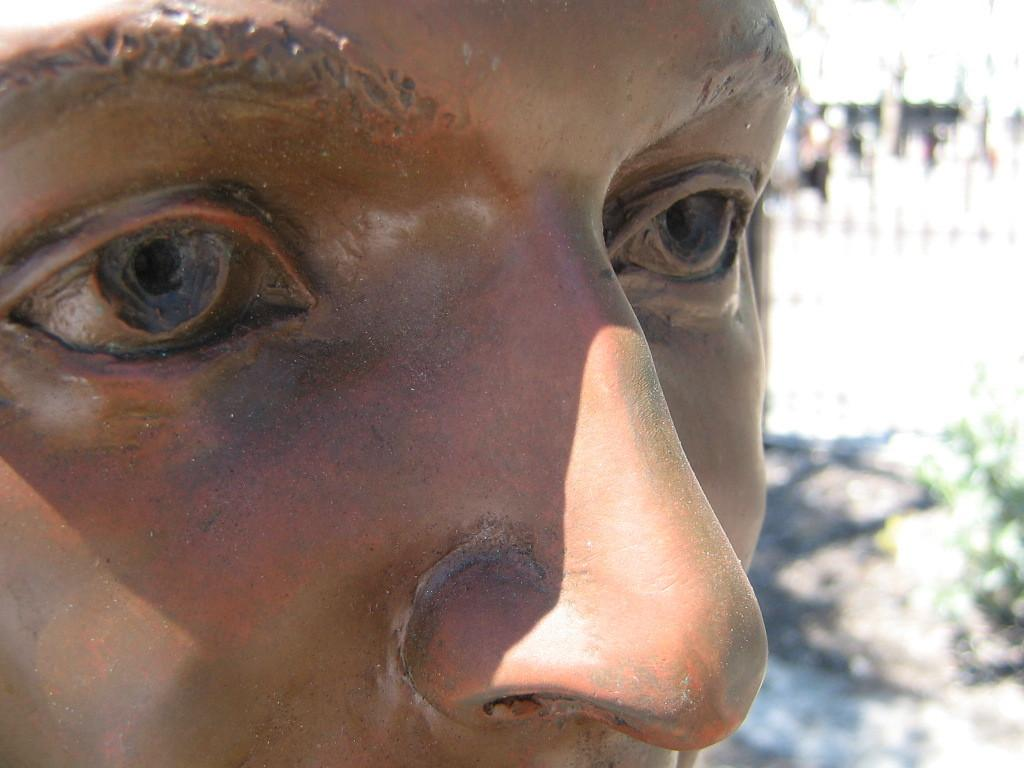What is the main subject of the image? There is a face in the image. Can you describe the background of the image? The background of the image is blurred. What type of writing can be seen on the face in the image? There is no writing present on the face in the image. What is the cause of the blurred background in the image? The cause of the blurred background in the image is not mentioned in the provided facts. 